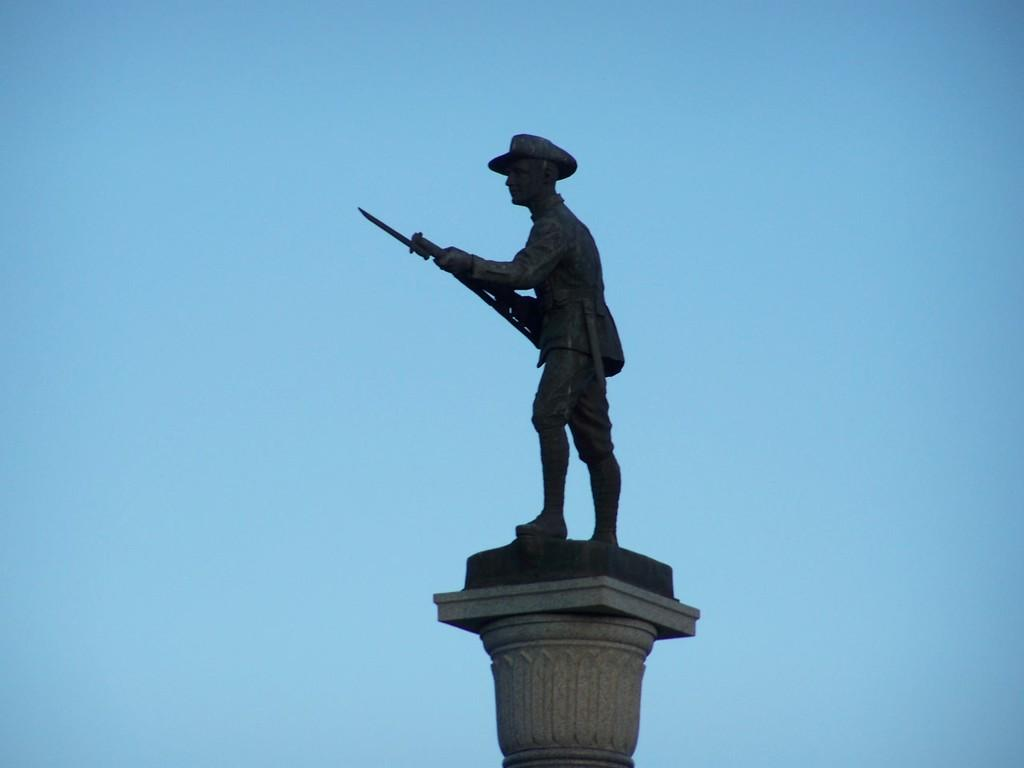Where was the image taken? The image is taken outdoors. What can be seen in the image besides the outdoor setting? There is a statue of a man in the image. What is the man in the statue holding? The man is holding a gun in his hands. How is the statue positioned in the image? The statue is on a pillar. What is visible in the background of the image? The sky is visible in the background of the image. How many baskets are hanging from the statue in the image? There are no baskets present in the image; the statue is holding a gun. What type of snakes can be seen slithering around the statue in the image? There are no snakes present in the image; the statue is holding a gun and standing on a pillar. 